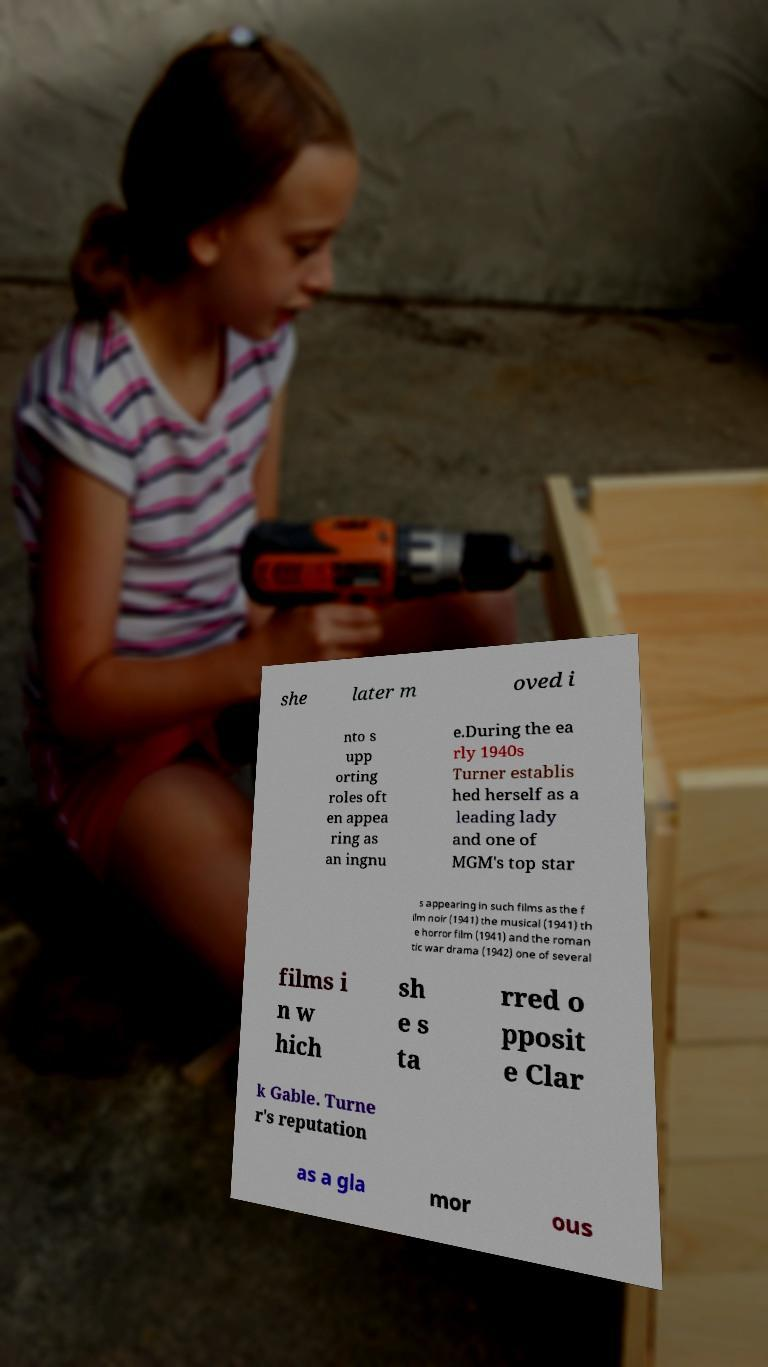I need the written content from this picture converted into text. Can you do that? she later m oved i nto s upp orting roles oft en appea ring as an ingnu e.During the ea rly 1940s Turner establis hed herself as a leading lady and one of MGM's top star s appearing in such films as the f ilm noir (1941) the musical (1941) th e horror film (1941) and the roman tic war drama (1942) one of several films i n w hich sh e s ta rred o pposit e Clar k Gable. Turne r's reputation as a gla mor ous 